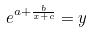Convert formula to latex. <formula><loc_0><loc_0><loc_500><loc_500>e ^ { a + \frac { b } { x + c } } = y</formula> 